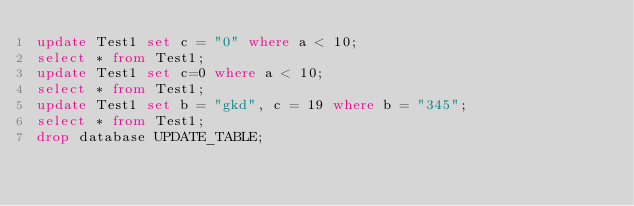Convert code to text. <code><loc_0><loc_0><loc_500><loc_500><_SQL_>update Test1 set c = "0" where a < 10;
select * from Test1;
update Test1 set c=0 where a < 10;
select * from Test1;
update Test1 set b = "gkd", c = 19 where b = "345";
select * from Test1;
drop database UPDATE_TABLE;</code> 